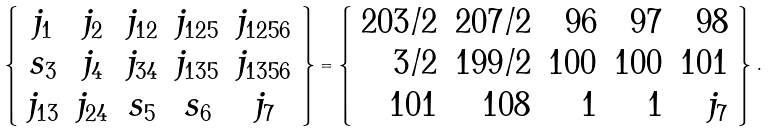<formula> <loc_0><loc_0><loc_500><loc_500>\left \{ \begin{array} { c c c c c } j _ { 1 } & j _ { 2 } & j _ { 1 2 } & j _ { 1 2 5 } & j _ { 1 2 5 6 } \\ s _ { 3 } & j _ { 4 } & j _ { 3 4 } & j _ { 1 3 5 } & j _ { 1 3 5 6 } \\ j _ { 1 3 } & j _ { 2 4 } & s _ { 5 } & s _ { 6 } & j _ { 7 } \\ \end{array} \right \} = \left \{ \begin{array} { r r r r r } 2 0 3 / 2 & 2 0 7 / 2 & 9 6 & 9 7 & 9 8 \\ 3 / 2 & 1 9 9 / 2 & 1 0 0 & 1 0 0 & 1 0 1 \\ 1 0 1 & 1 0 8 & 1 & 1 & j _ { 7 } \\ \end{array} \right \} \, .</formula> 